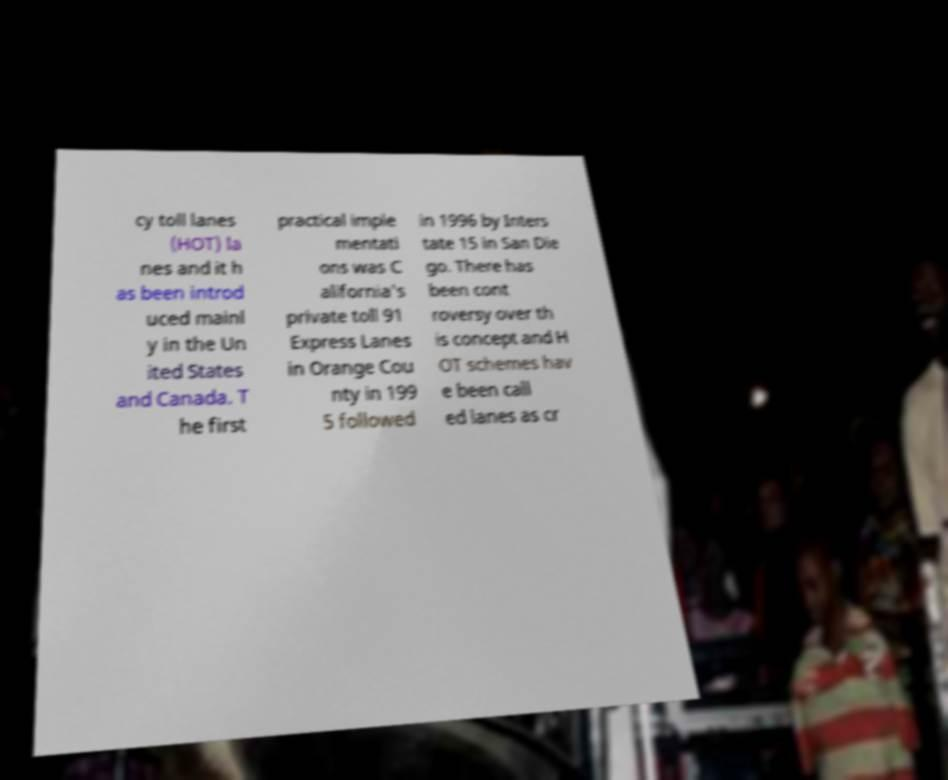What messages or text are displayed in this image? I need them in a readable, typed format. cy toll lanes (HOT) la nes and it h as been introd uced mainl y in the Un ited States and Canada. T he first practical imple mentati ons was C alifornia's private toll 91 Express Lanes in Orange Cou nty in 199 5 followed in 1996 by Inters tate 15 in San Die go. There has been cont roversy over th is concept and H OT schemes hav e been call ed lanes as cr 